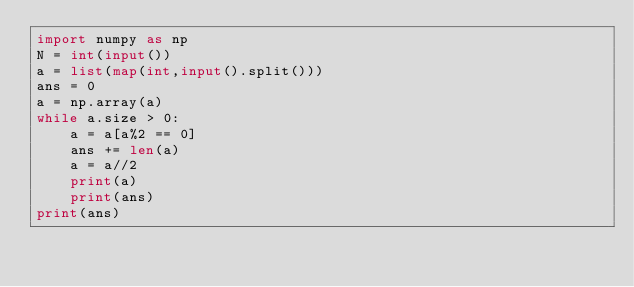<code> <loc_0><loc_0><loc_500><loc_500><_Python_>import numpy as np
N = int(input())
a = list(map(int,input().split()))
ans = 0
a = np.array(a)
while a.size > 0:
    a = a[a%2 == 0]
    ans += len(a)
    a = a//2
    print(a)
    print(ans)
print(ans)</code> 